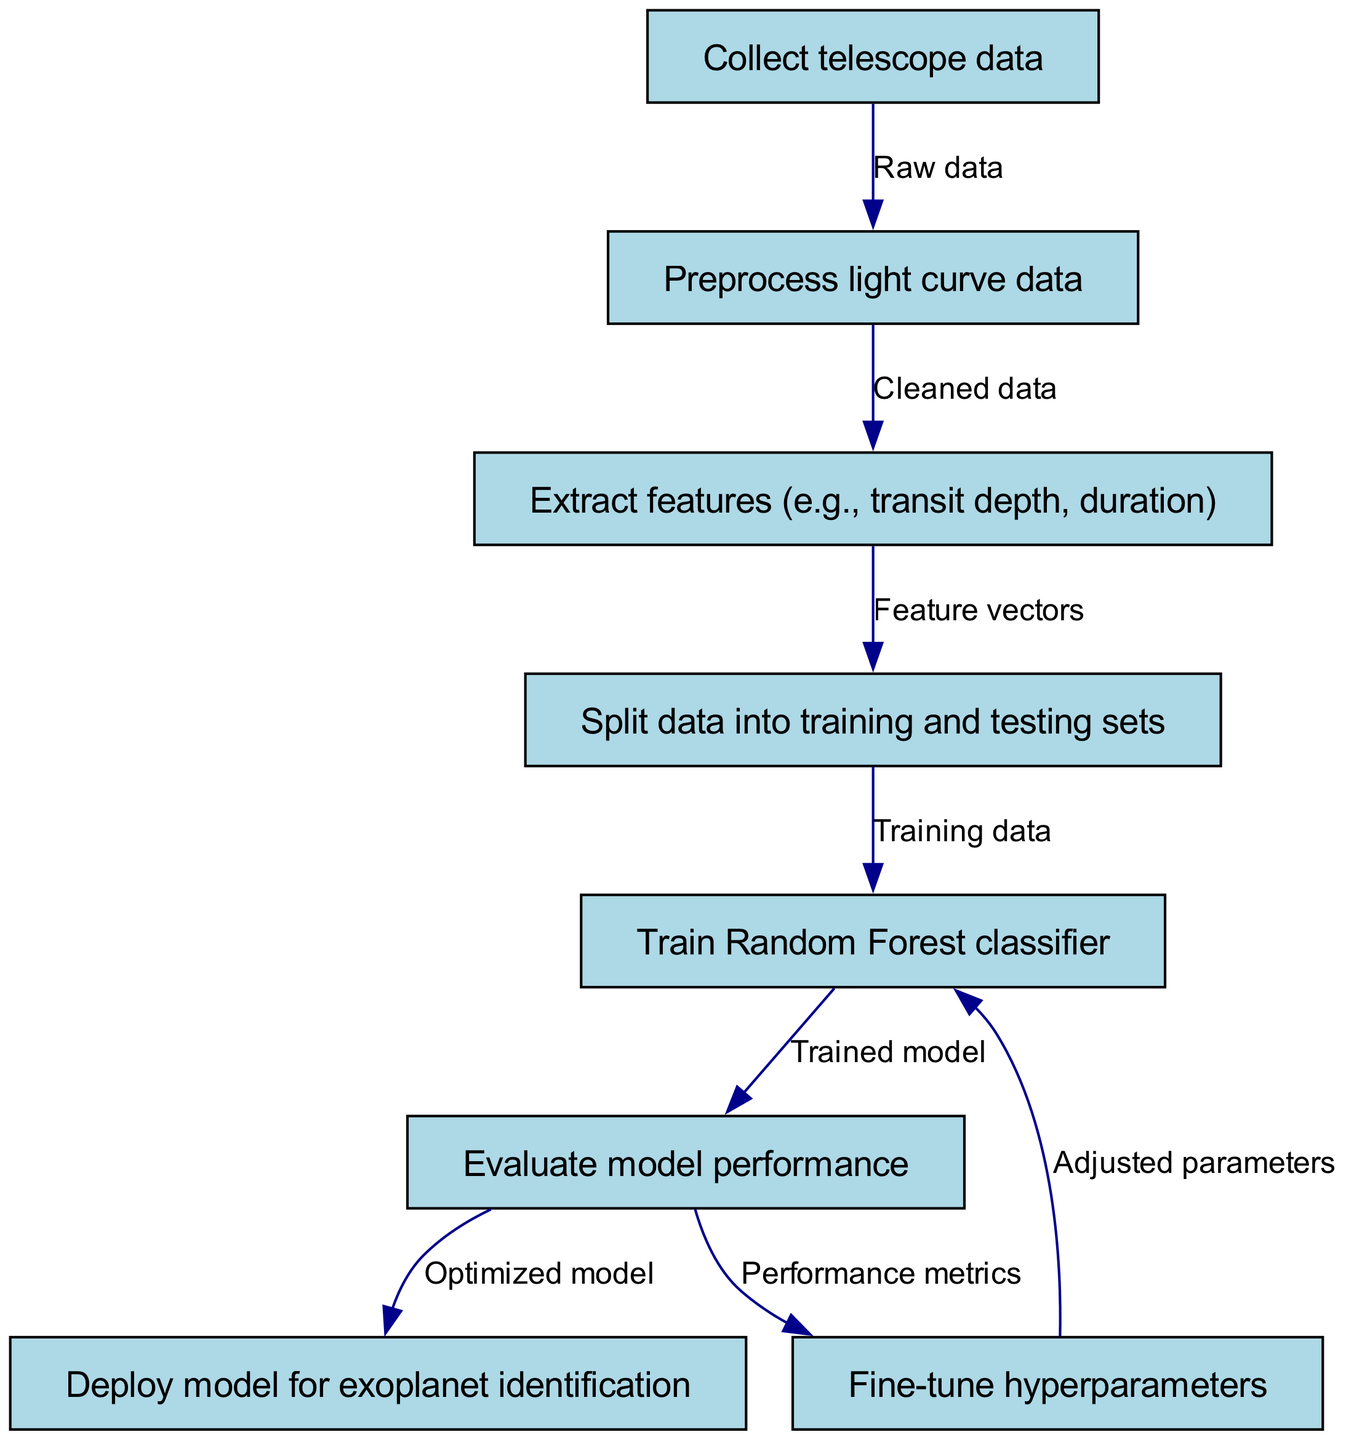What is the first step in the machine learning model training process? The diagram shows the initial node labeled "Collect telescope data," indicating that this is the first action required before any further steps can be taken.
Answer: Collect telescope data How many nodes are present in the diagram? The diagram contains a total of eight nodes, which represent different stages in the machine learning process, as detailed in the provided data.
Answer: Eight What type of classifier is trained in the process? Upon examining the node labeled "Train Random Forest classifier," it is clear that the specific type of classifier being utilized in this training process is a Random Forest classifier.
Answer: Random Forest classifier What is the output of the evaluation step? After the "Evaluate model performance" node, the output is denoted as "Performance metrics," signifying that the results of the evaluation are summarized in metrics relevant to model performance.
Answer: Performance metrics What happens after fine-tuning hyperparameters? According to the diagram, after "Fine-tune hyperparameters," the process resumes at the "Train Random Forest classifier" node, suggesting that adjustments made during fine-tuning are used to improve the model training phase.
Answer: Adjusted parameters How many edges connect the nodes in the diagram? The diagram illustrates a total of seven edges, representing the connections and flow of information between the stages of the machine learning model's training process.
Answer: Seven What is the final step in the diagram? The concluding action depicted in the diagram is "Deploy model for exoplanet identification," indicating the end goal of the training process where the model is put into practical use.
Answer: Deploy model for exoplanet identification What data is necessary before preprocessing? The initial node states "Collect telescope data," demonstrating the prerequisite data necessary prior to any preprocessing steps.
Answer: Raw data 